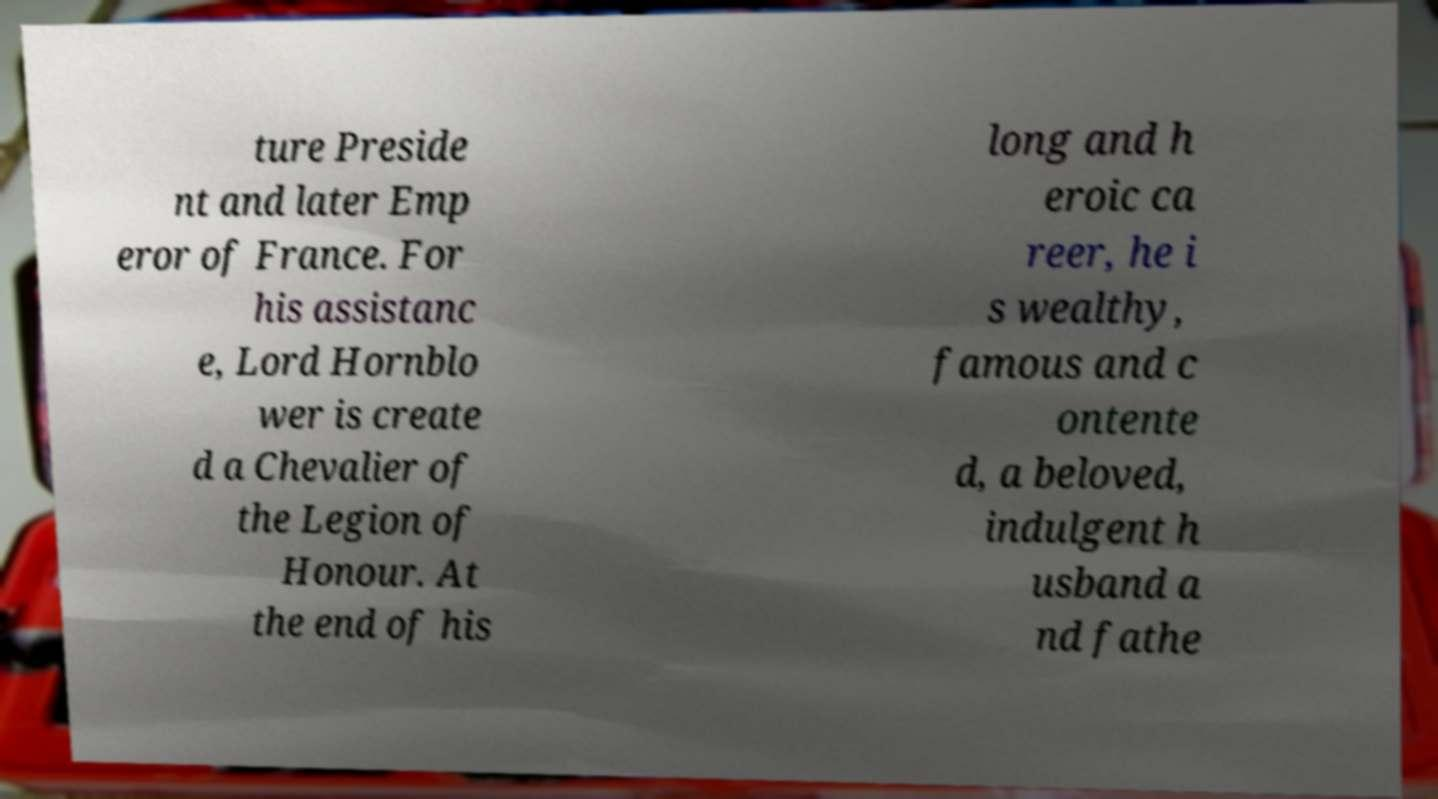Please read and relay the text visible in this image. What does it say? ture Preside nt and later Emp eror of France. For his assistanc e, Lord Hornblo wer is create d a Chevalier of the Legion of Honour. At the end of his long and h eroic ca reer, he i s wealthy, famous and c ontente d, a beloved, indulgent h usband a nd fathe 